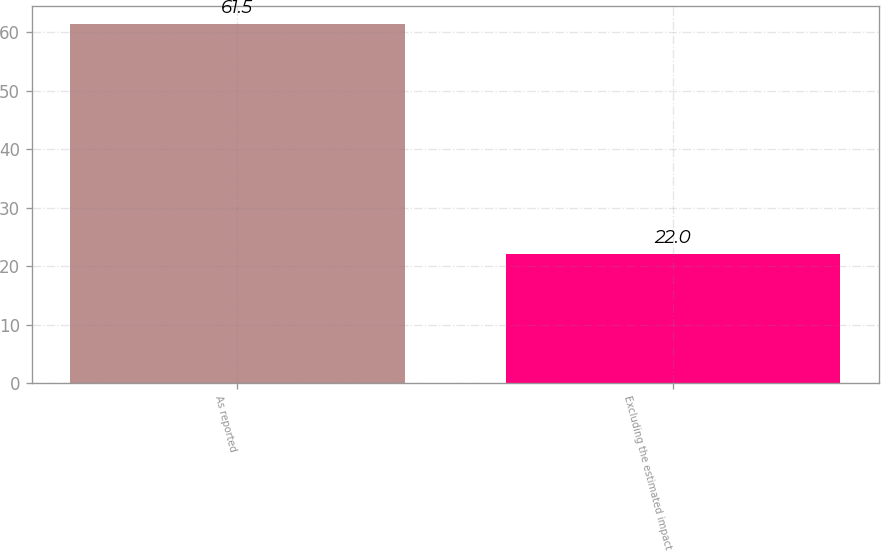Convert chart to OTSL. <chart><loc_0><loc_0><loc_500><loc_500><bar_chart><fcel>As reported<fcel>Excluding the estimated impact<nl><fcel>61.5<fcel>22<nl></chart> 